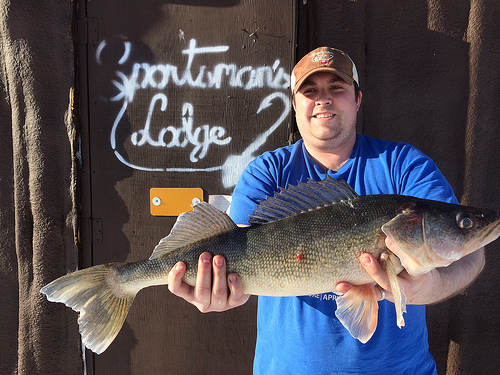<image>
Can you confirm if the man is in front of the fish? No. The man is not in front of the fish. The spatial positioning shows a different relationship between these objects. 